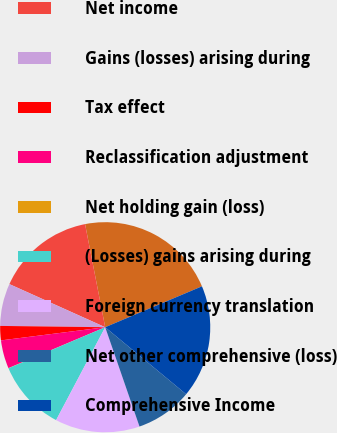Convert chart to OTSL. <chart><loc_0><loc_0><loc_500><loc_500><pie_chart><fcel>Year Ended December 31<fcel>Net income<fcel>Gains (losses) arising during<fcel>Tax effect<fcel>Reclassification adjustment<fcel>Net holding gain (loss)<fcel>(Losses) gains arising during<fcel>Foreign currency translation<fcel>Net other comprehensive (loss)<fcel>Comprehensive Income<nl><fcel>21.7%<fcel>15.2%<fcel>6.53%<fcel>2.2%<fcel>4.36%<fcel>0.03%<fcel>10.87%<fcel>13.03%<fcel>8.7%<fcel>17.37%<nl></chart> 